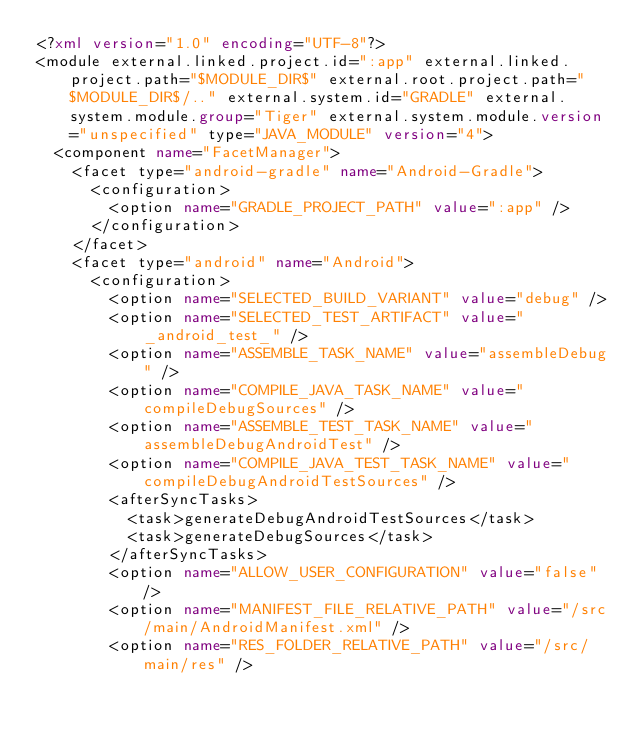Convert code to text. <code><loc_0><loc_0><loc_500><loc_500><_XML_><?xml version="1.0" encoding="UTF-8"?>
<module external.linked.project.id=":app" external.linked.project.path="$MODULE_DIR$" external.root.project.path="$MODULE_DIR$/.." external.system.id="GRADLE" external.system.module.group="Tiger" external.system.module.version="unspecified" type="JAVA_MODULE" version="4">
  <component name="FacetManager">
    <facet type="android-gradle" name="Android-Gradle">
      <configuration>
        <option name="GRADLE_PROJECT_PATH" value=":app" />
      </configuration>
    </facet>
    <facet type="android" name="Android">
      <configuration>
        <option name="SELECTED_BUILD_VARIANT" value="debug" />
        <option name="SELECTED_TEST_ARTIFACT" value="_android_test_" />
        <option name="ASSEMBLE_TASK_NAME" value="assembleDebug" />
        <option name="COMPILE_JAVA_TASK_NAME" value="compileDebugSources" />
        <option name="ASSEMBLE_TEST_TASK_NAME" value="assembleDebugAndroidTest" />
        <option name="COMPILE_JAVA_TEST_TASK_NAME" value="compileDebugAndroidTestSources" />
        <afterSyncTasks>
          <task>generateDebugAndroidTestSources</task>
          <task>generateDebugSources</task>
        </afterSyncTasks>
        <option name="ALLOW_USER_CONFIGURATION" value="false" />
        <option name="MANIFEST_FILE_RELATIVE_PATH" value="/src/main/AndroidManifest.xml" />
        <option name="RES_FOLDER_RELATIVE_PATH" value="/src/main/res" /></code> 